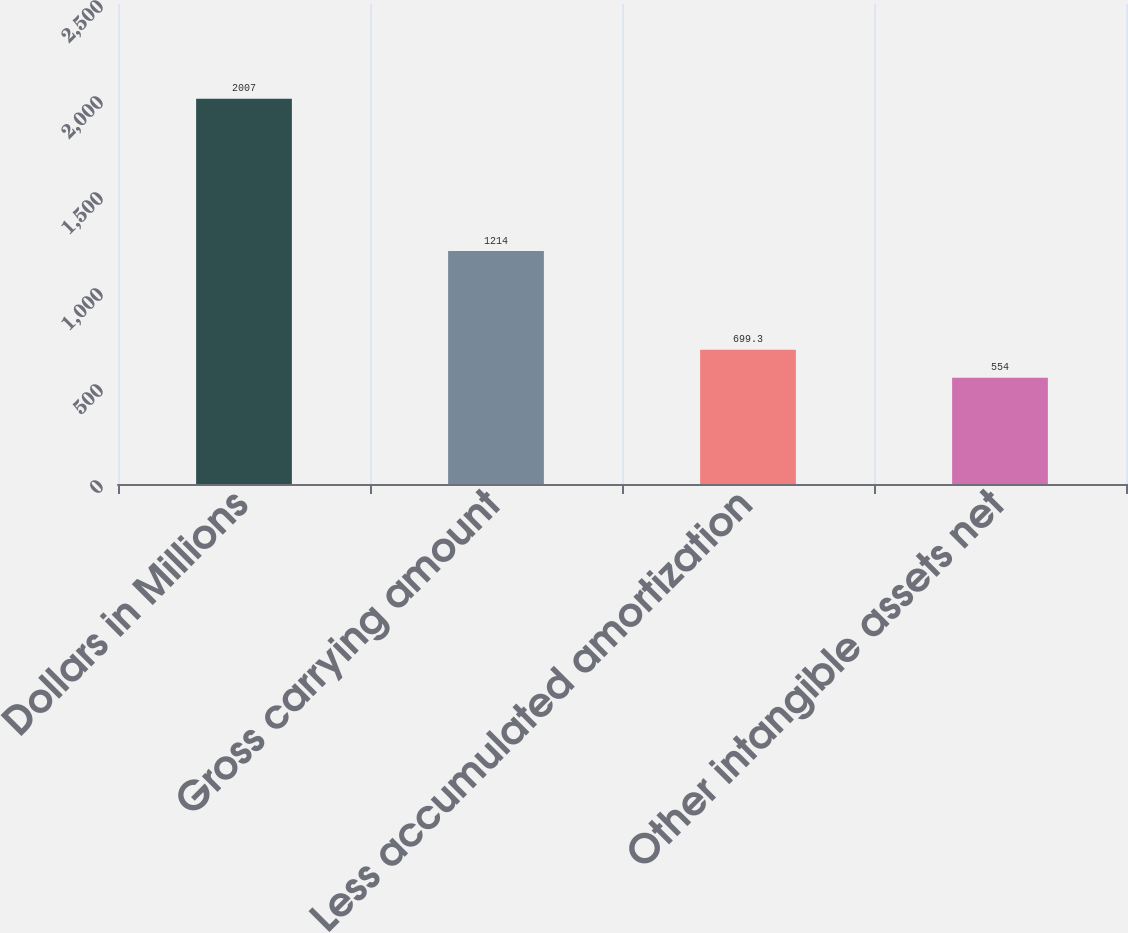Convert chart. <chart><loc_0><loc_0><loc_500><loc_500><bar_chart><fcel>Dollars in Millions<fcel>Gross carrying amount<fcel>Less accumulated amortization<fcel>Other intangible assets net<nl><fcel>2007<fcel>1214<fcel>699.3<fcel>554<nl></chart> 